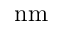<formula> <loc_0><loc_0><loc_500><loc_500>n m</formula> 